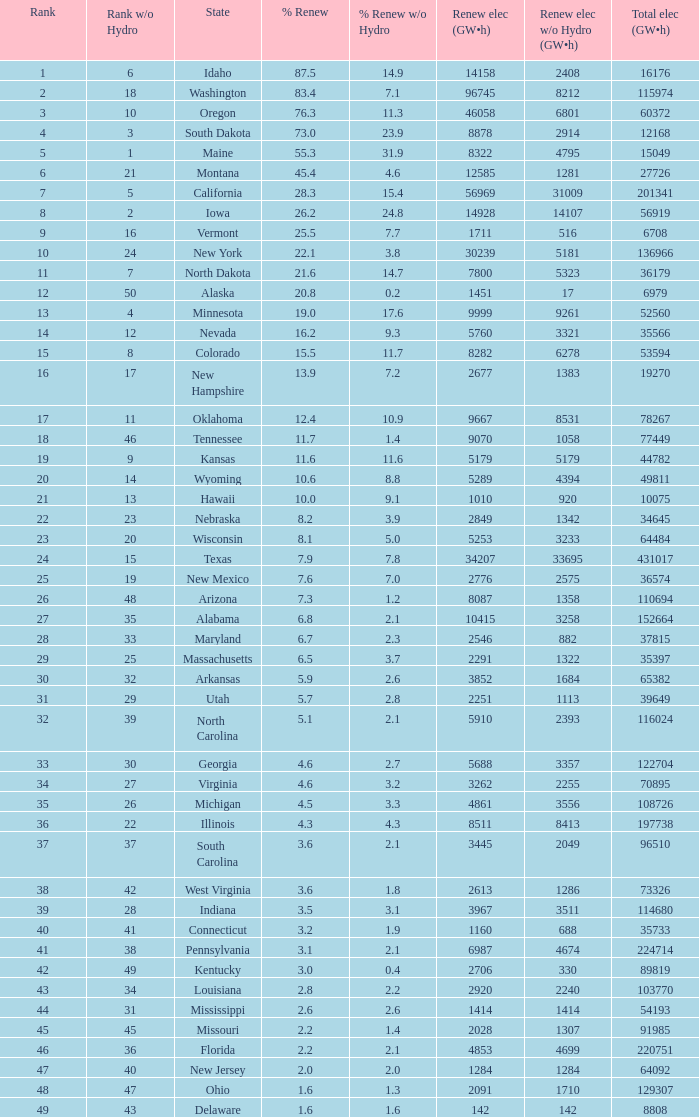What is the utmost renewable energy (gw×h) for the state of delaware? 142.0. 